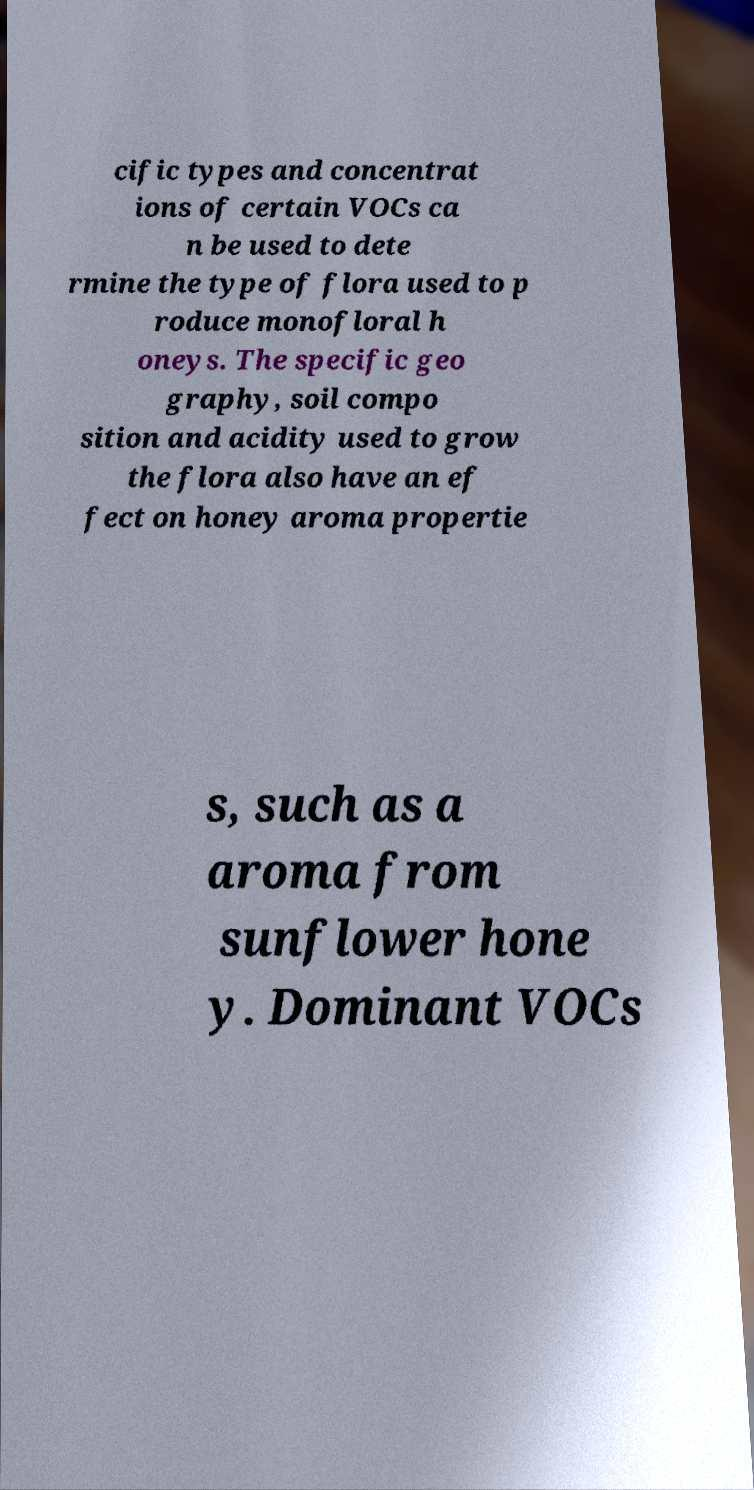Could you assist in decoding the text presented in this image and type it out clearly? cific types and concentrat ions of certain VOCs ca n be used to dete rmine the type of flora used to p roduce monofloral h oneys. The specific geo graphy, soil compo sition and acidity used to grow the flora also have an ef fect on honey aroma propertie s, such as a aroma from sunflower hone y. Dominant VOCs 